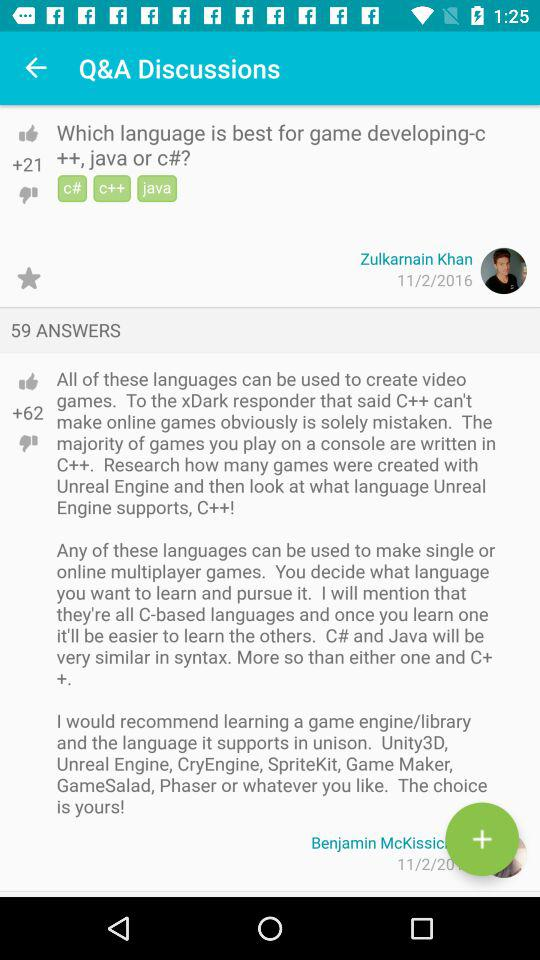How many answers are there to the question 'Which language is best for game developing-c ++, java or c#?'
Answer the question using a single word or phrase. 59 